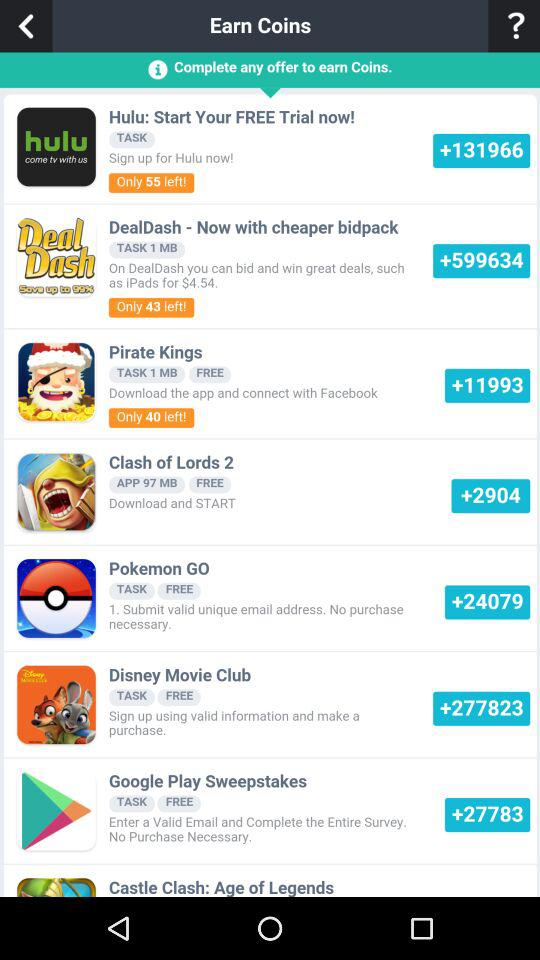How many coins can you earn with the "Google Play Sweepstakes"? You can earn more than 27783 coins. 